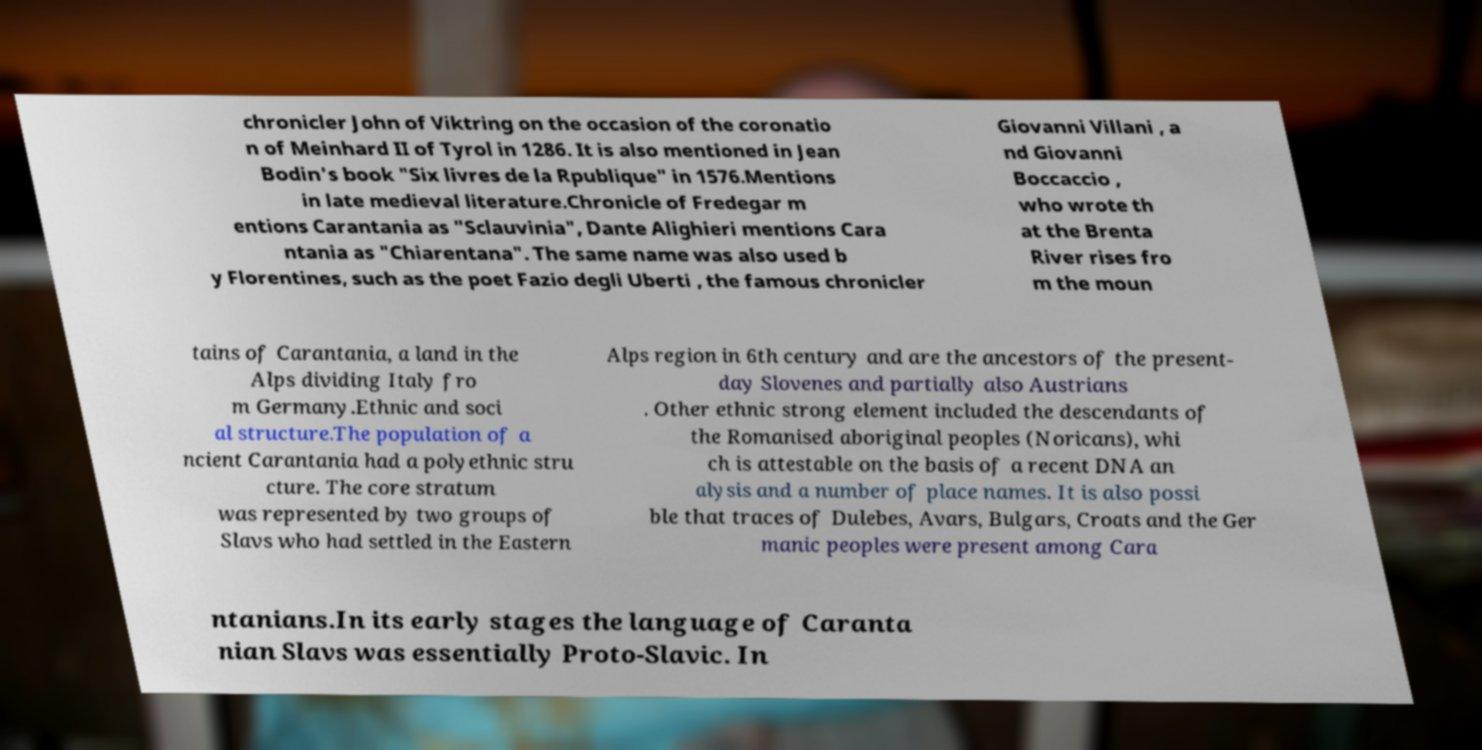Please identify and transcribe the text found in this image. chronicler John of Viktring on the occasion of the coronatio n of Meinhard II of Tyrol in 1286. It is also mentioned in Jean Bodin's book "Six livres de la Rpublique" in 1576.Mentions in late medieval literature.Chronicle of Fredegar m entions Carantania as "Sclauvinia", Dante Alighieri mentions Cara ntania as "Chiarentana". The same name was also used b y Florentines, such as the poet Fazio degli Uberti , the famous chronicler Giovanni Villani , a nd Giovanni Boccaccio , who wrote th at the Brenta River rises fro m the moun tains of Carantania, a land in the Alps dividing Italy fro m Germany.Ethnic and soci al structure.The population of a ncient Carantania had a polyethnic stru cture. The core stratum was represented by two groups of Slavs who had settled in the Eastern Alps region in 6th century and are the ancestors of the present- day Slovenes and partially also Austrians . Other ethnic strong element included the descendants of the Romanised aboriginal peoples (Noricans), whi ch is attestable on the basis of a recent DNA an alysis and a number of place names. It is also possi ble that traces of Dulebes, Avars, Bulgars, Croats and the Ger manic peoples were present among Cara ntanians.In its early stages the language of Caranta nian Slavs was essentially Proto-Slavic. In 